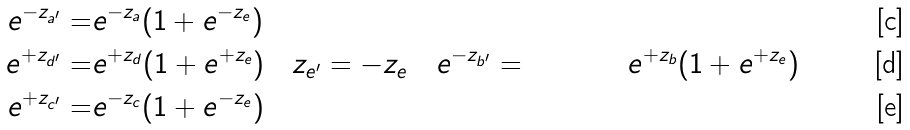Convert formula to latex. <formula><loc_0><loc_0><loc_500><loc_500>e ^ { - z _ { a ^ { \prime } } } = & e ^ { - z _ { a } } ( 1 + e ^ { - z _ { e } } ) \\ e ^ { + z _ { d ^ { \prime } } } = & e ^ { + z _ { d } } ( 1 + e ^ { + z _ { e } } ) \quad z _ { e ^ { \prime } } = - z _ { e } \quad e ^ { - z _ { b ^ { \prime } } } = & e ^ { + z _ { b } } ( 1 + e ^ { + z _ { e } } ) \\ e ^ { + z _ { c ^ { \prime } } } = & e ^ { - z _ { c } } ( 1 + e ^ { - z _ { e } } )</formula> 